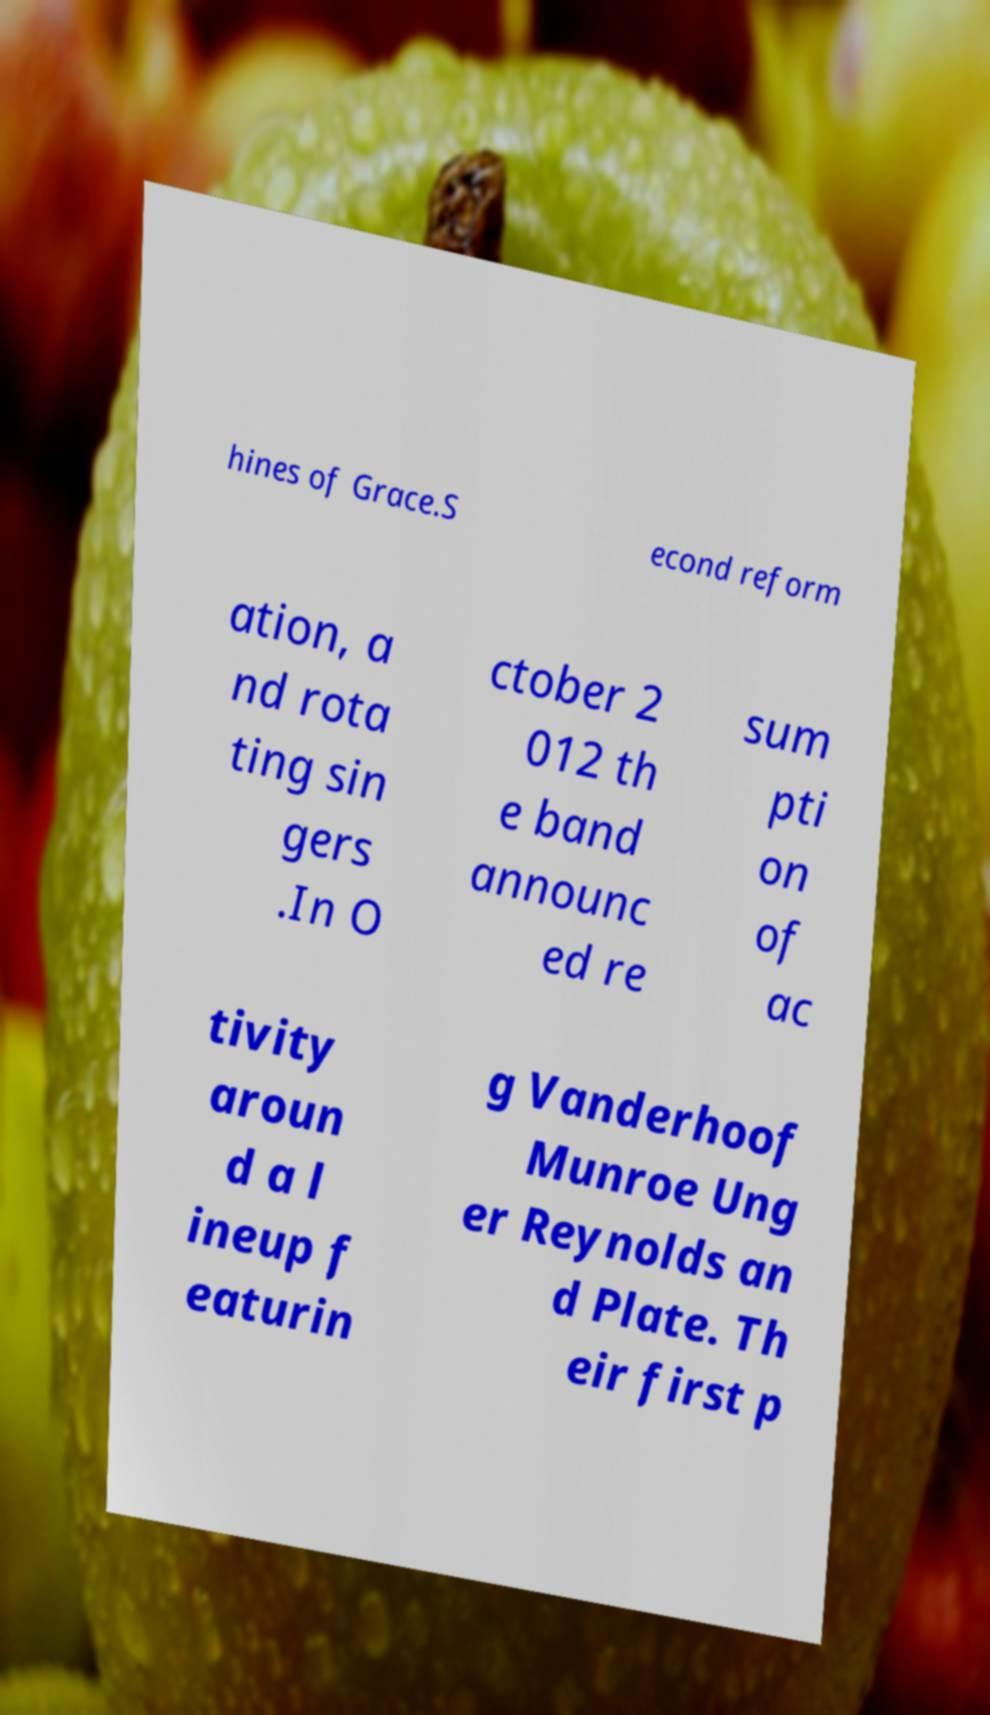Could you extract and type out the text from this image? hines of Grace.S econd reform ation, a nd rota ting sin gers .In O ctober 2 012 th e band announc ed re sum pti on of ac tivity aroun d a l ineup f eaturin g Vanderhoof Munroe Ung er Reynolds an d Plate. Th eir first p 